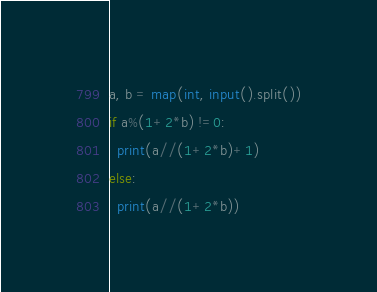<code> <loc_0><loc_0><loc_500><loc_500><_Python_>a, b = map(int, input().split())
if a%(1+2*b) !=0:
  print(a//(1+2*b)+1)
else:
  print(a//(1+2*b))</code> 